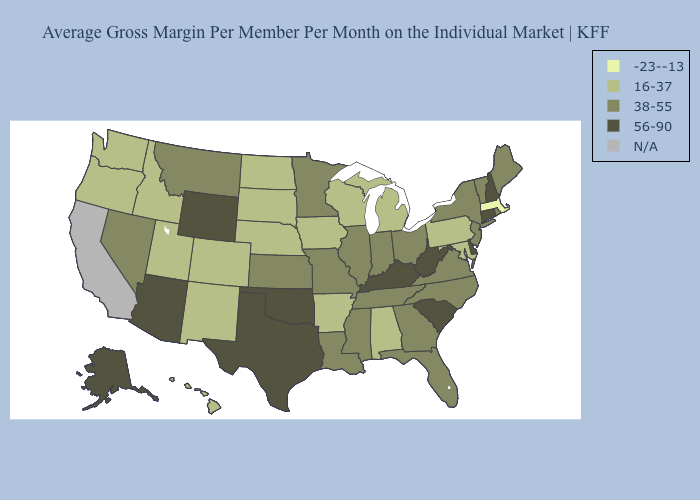Among the states that border West Virginia , does Pennsylvania have the highest value?
Keep it brief. No. Among the states that border Washington , which have the lowest value?
Be succinct. Idaho, Oregon. Name the states that have a value in the range N/A?
Concise answer only. California. Name the states that have a value in the range -23--13?
Short answer required. Massachusetts. Name the states that have a value in the range 56-90?
Write a very short answer. Alaska, Arizona, Connecticut, Delaware, Kentucky, New Hampshire, Oklahoma, South Carolina, Texas, West Virginia, Wyoming. What is the lowest value in the MidWest?
Answer briefly. 16-37. Name the states that have a value in the range 38-55?
Give a very brief answer. Florida, Georgia, Illinois, Indiana, Kansas, Louisiana, Maine, Minnesota, Mississippi, Missouri, Montana, Nevada, New Jersey, New York, North Carolina, Ohio, Rhode Island, Tennessee, Vermont, Virginia. What is the value of Tennessee?
Answer briefly. 38-55. Name the states that have a value in the range 16-37?
Concise answer only. Alabama, Arkansas, Colorado, Hawaii, Idaho, Iowa, Maryland, Michigan, Nebraska, New Mexico, North Dakota, Oregon, Pennsylvania, South Dakota, Utah, Washington, Wisconsin. Does the first symbol in the legend represent the smallest category?
Short answer required. Yes. Among the states that border Colorado , which have the lowest value?
Quick response, please. Nebraska, New Mexico, Utah. Is the legend a continuous bar?
Quick response, please. No. Does Rhode Island have the lowest value in the USA?
Short answer required. No. 